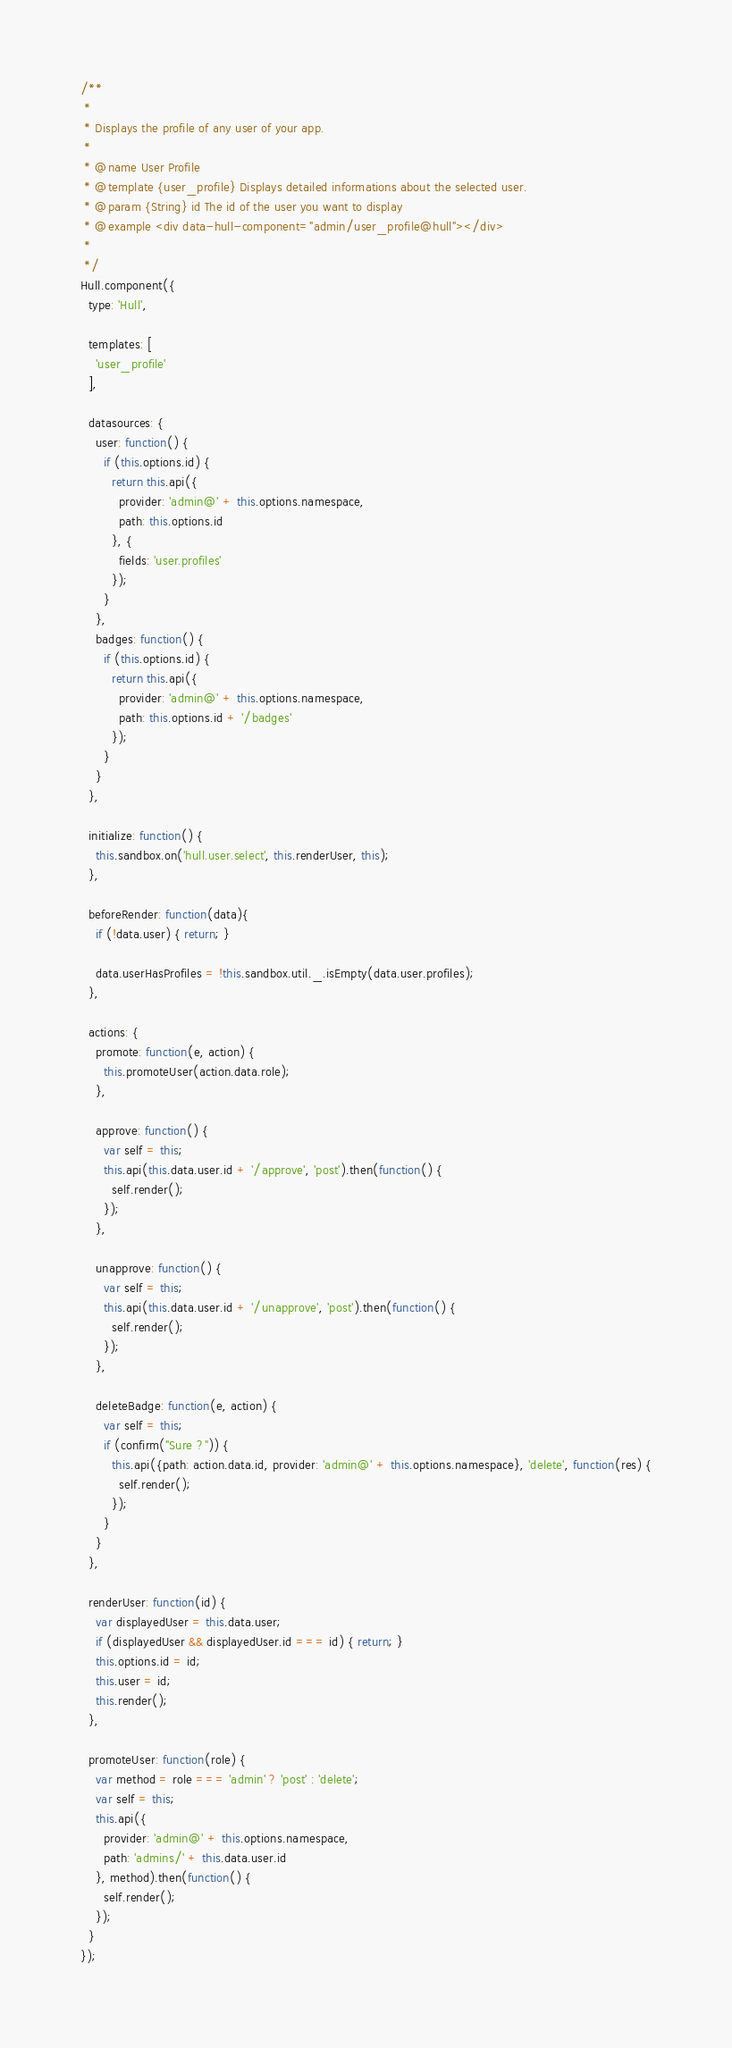Convert code to text. <code><loc_0><loc_0><loc_500><loc_500><_JavaScript_>/**
 *
 * Displays the profile of any user of your app.
 *
 * @name User Profile
 * @template {user_profile} Displays detailed informations about the selected user.
 * @param {String} id The id of the user you want to display
 * @example <div data-hull-component="admin/user_profile@hull"></div>
 *
 */
Hull.component({
  type: 'Hull',

  templates: [
    'user_profile'
  ],

  datasources: {
    user: function() {
      if (this.options.id) {
        return this.api({
          provider: 'admin@' + this.options.namespace,
          path: this.options.id
        }, {
          fields: 'user.profiles'
        });
      }
    },
    badges: function() {
      if (this.options.id) {
        return this.api({
          provider: 'admin@' + this.options.namespace,
          path: this.options.id + '/badges'
        });
      }
    }
  },

  initialize: function() {
    this.sandbox.on('hull.user.select', this.renderUser, this);
  },

  beforeRender: function(data){
    if (!data.user) { return; }

    data.userHasProfiles = !this.sandbox.util._.isEmpty(data.user.profiles);
  },

  actions: {
    promote: function(e, action) {
      this.promoteUser(action.data.role);
    },

    approve: function() {
      var self = this;
      this.api(this.data.user.id + '/approve', 'post').then(function() {
        self.render();
      });
    },

    unapprove: function() {
      var self = this;
      this.api(this.data.user.id + '/unapprove', 'post').then(function() {
        self.render();
      });
    },

    deleteBadge: function(e, action) {
      var self = this;
      if (confirm("Sure ?")) {
        this.api({path: action.data.id, provider: 'admin@' + this.options.namespace}, 'delete', function(res) {
          self.render();
        });
      }
    }
  },

  renderUser: function(id) {
    var displayedUser = this.data.user;
    if (displayedUser && displayedUser.id === id) { return; }
    this.options.id = id;
    this.user = id;
    this.render();
  },

  promoteUser: function(role) {
    var method = role === 'admin' ? 'post' : 'delete';
    var self = this;
    this.api({
      provider: 'admin@' + this.options.namespace,
      path: 'admins/' + this.data.user.id
    }, method).then(function() {
      self.render();
    });
  }
});
</code> 